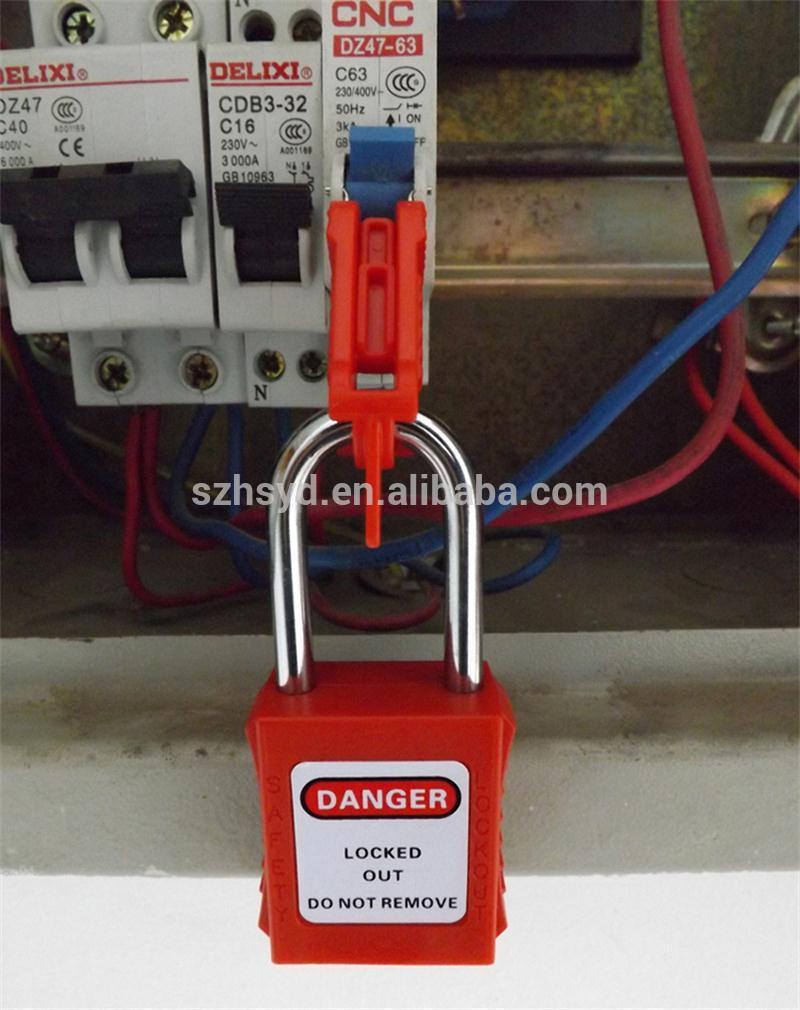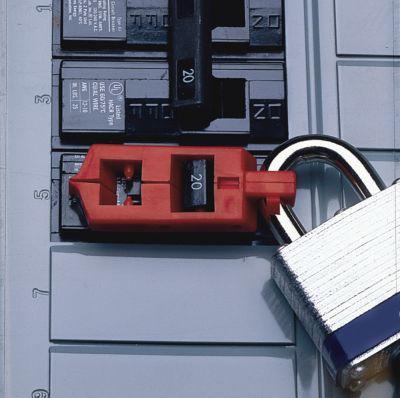The first image is the image on the left, the second image is the image on the right. Assess this claim about the two images: "Red and white stripes are visible in one of the images.". Correct or not? Answer yes or no. No. 